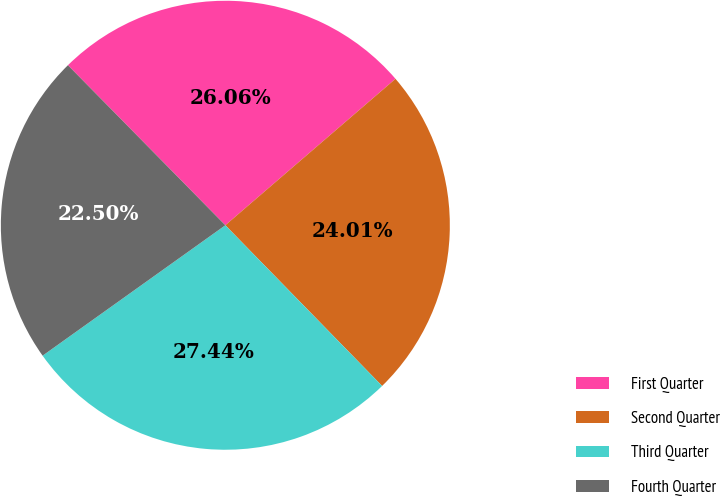Convert chart to OTSL. <chart><loc_0><loc_0><loc_500><loc_500><pie_chart><fcel>First Quarter<fcel>Second Quarter<fcel>Third Quarter<fcel>Fourth Quarter<nl><fcel>26.06%<fcel>24.01%<fcel>27.44%<fcel>22.5%<nl></chart> 